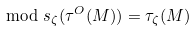<formula> <loc_0><loc_0><loc_500><loc_500>\mod s _ { \zeta } ( \tau ^ { O } ( M ) ) = \tau _ { \zeta } ( M )</formula> 